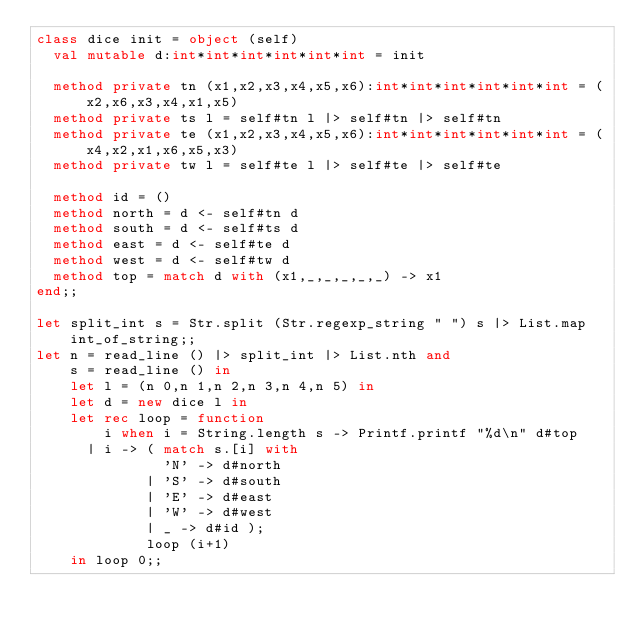<code> <loc_0><loc_0><loc_500><loc_500><_OCaml_>class dice init = object (self)
  val mutable d:int*int*int*int*int*int = init

  method private tn (x1,x2,x3,x4,x5,x6):int*int*int*int*int*int = (x2,x6,x3,x4,x1,x5)
  method private ts l = self#tn l |> self#tn |> self#tn
  method private te (x1,x2,x3,x4,x5,x6):int*int*int*int*int*int = (x4,x2,x1,x6,x5,x3)
  method private tw l = self#te l |> self#te |> self#te

  method id = ()
  method north = d <- self#tn d
  method south = d <- self#ts d
  method east = d <- self#te d
  method west = d <- self#tw d
  method top = match d with (x1,_,_,_,_,_) -> x1
end;;

let split_int s = Str.split (Str.regexp_string " ") s |> List.map int_of_string;;
let n = read_line () |> split_int |> List.nth and
    s = read_line () in
    let l = (n 0,n 1,n 2,n 3,n 4,n 5) in
    let d = new dice l in
    let rec loop = function
        i when i = String.length s -> Printf.printf "%d\n" d#top
      | i -> ( match s.[i] with
               'N' -> d#north
             | 'S' -> d#south
             | 'E' -> d#east
             | 'W' -> d#west
             | _ -> d#id );
             loop (i+1)
    in loop 0;;</code> 